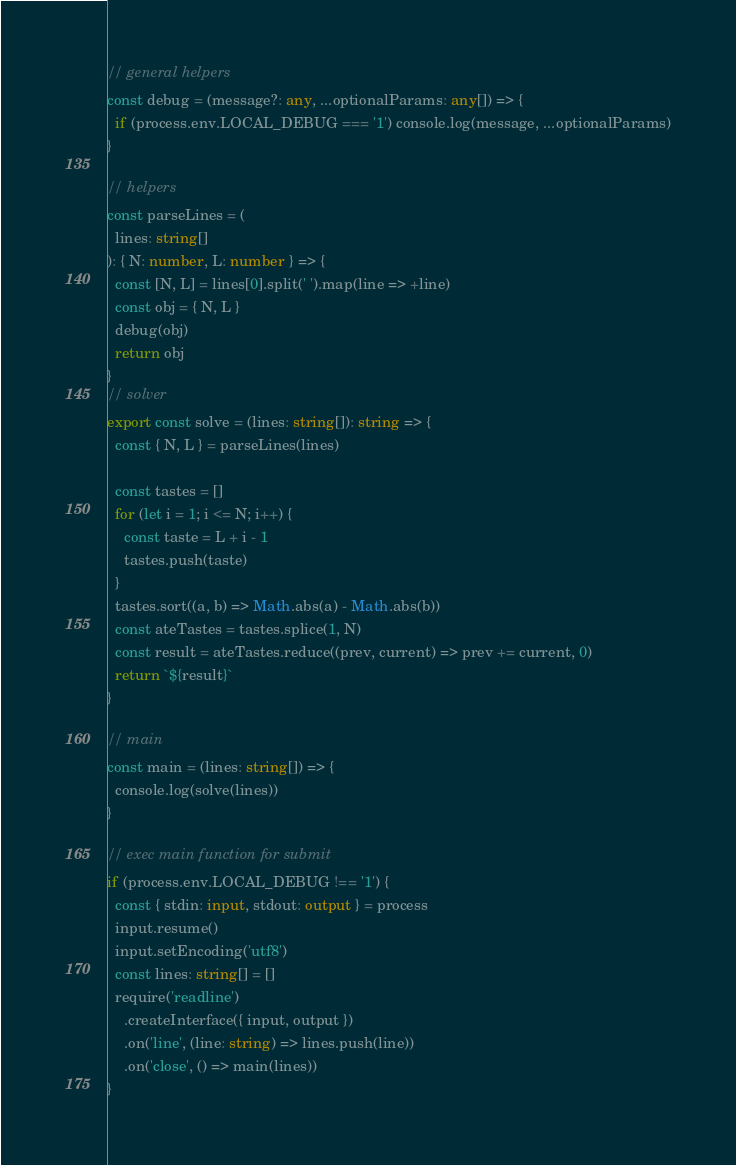Convert code to text. <code><loc_0><loc_0><loc_500><loc_500><_TypeScript_>// general helpers
const debug = (message?: any, ...optionalParams: any[]) => {
  if (process.env.LOCAL_DEBUG === '1') console.log(message, ...optionalParams)
}

// helpers
const parseLines = (
  lines: string[]
): { N: number, L: number } => {
  const [N, L] = lines[0].split(' ').map(line => +line)
  const obj = { N, L }
  debug(obj)
  return obj
}
// solver
export const solve = (lines: string[]): string => {
  const { N, L } = parseLines(lines)

  const tastes = []
  for (let i = 1; i <= N; i++) {
    const taste = L + i - 1
    tastes.push(taste)
  }
  tastes.sort((a, b) => Math.abs(a) - Math.abs(b))
  const ateTastes = tastes.splice(1, N)
  const result = ateTastes.reduce((prev, current) => prev += current, 0)
  return `${result}`
}

// main
const main = (lines: string[]) => {
  console.log(solve(lines))
}

// exec main function for submit
if (process.env.LOCAL_DEBUG !== '1') {
  const { stdin: input, stdout: output } = process
  input.resume()
  input.setEncoding('utf8')
  const lines: string[] = []
  require('readline')
    .createInterface({ input, output })
    .on('line', (line: string) => lines.push(line))
    .on('close', () => main(lines))
}
</code> 